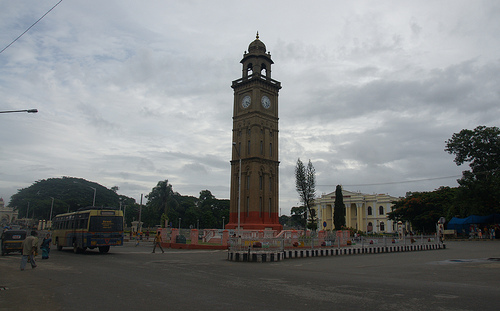Can you tell me more about the surroundings of the clock tower? The clock tower is situated at a junction with some barricades around it, indicating possible street work or an area of restricted access. Nearby, there are typical urban elements such as a bus, buildings with mixed designs, and a few pedestrians, reflecting an active yet not overcrowded street scene. 